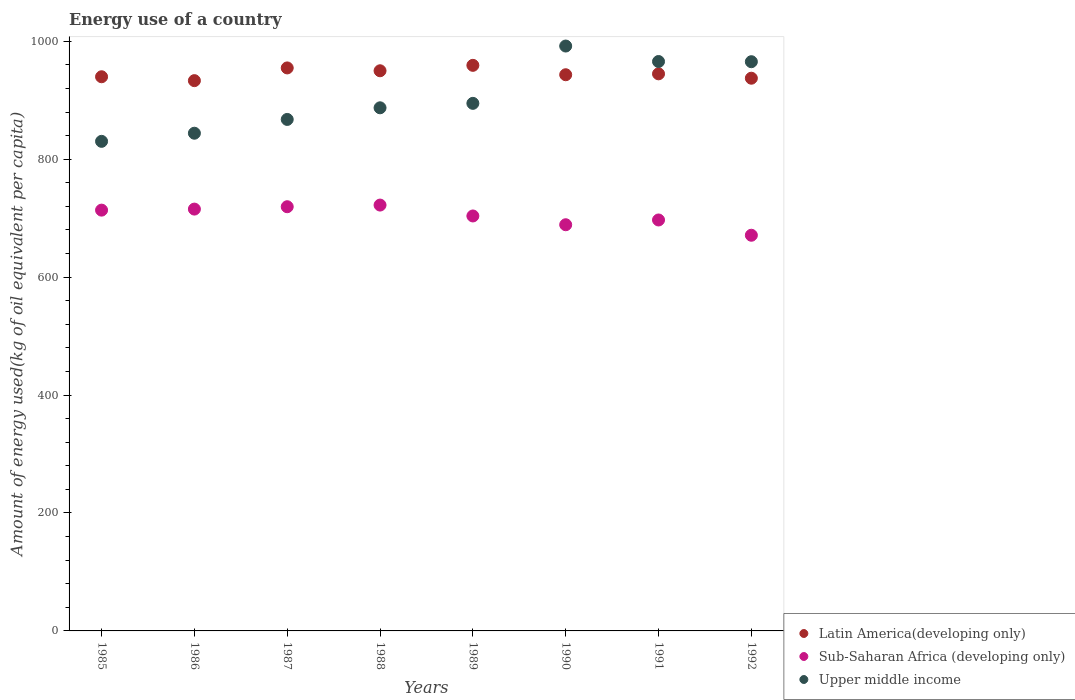How many different coloured dotlines are there?
Provide a short and direct response. 3. Is the number of dotlines equal to the number of legend labels?
Your response must be concise. Yes. What is the amount of energy used in in Sub-Saharan Africa (developing only) in 1987?
Provide a short and direct response. 719.36. Across all years, what is the maximum amount of energy used in in Sub-Saharan Africa (developing only)?
Your answer should be very brief. 722.16. Across all years, what is the minimum amount of energy used in in Latin America(developing only)?
Keep it short and to the point. 933.17. What is the total amount of energy used in in Upper middle income in the graph?
Make the answer very short. 7246.2. What is the difference between the amount of energy used in in Sub-Saharan Africa (developing only) in 1986 and that in 1991?
Make the answer very short. 18.45. What is the difference between the amount of energy used in in Latin America(developing only) in 1989 and the amount of energy used in in Upper middle income in 1990?
Your answer should be compact. -32.74. What is the average amount of energy used in in Sub-Saharan Africa (developing only) per year?
Provide a succinct answer. 703.86. In the year 1992, what is the difference between the amount of energy used in in Upper middle income and amount of energy used in in Sub-Saharan Africa (developing only)?
Keep it short and to the point. 294.29. What is the ratio of the amount of energy used in in Latin America(developing only) in 1987 to that in 1992?
Give a very brief answer. 1.02. Is the amount of energy used in in Latin America(developing only) in 1986 less than that in 1988?
Offer a very short reply. Yes. What is the difference between the highest and the second highest amount of energy used in in Sub-Saharan Africa (developing only)?
Ensure brevity in your answer.  2.8. What is the difference between the highest and the lowest amount of energy used in in Sub-Saharan Africa (developing only)?
Your response must be concise. 51.16. Is it the case that in every year, the sum of the amount of energy used in in Sub-Saharan Africa (developing only) and amount of energy used in in Latin America(developing only)  is greater than the amount of energy used in in Upper middle income?
Make the answer very short. Yes. Is the amount of energy used in in Latin America(developing only) strictly greater than the amount of energy used in in Upper middle income over the years?
Keep it short and to the point. No. Is the amount of energy used in in Upper middle income strictly less than the amount of energy used in in Latin America(developing only) over the years?
Your answer should be very brief. No. How many dotlines are there?
Your answer should be compact. 3. Are the values on the major ticks of Y-axis written in scientific E-notation?
Your answer should be very brief. No. How many legend labels are there?
Your response must be concise. 3. What is the title of the graph?
Provide a short and direct response. Energy use of a country. What is the label or title of the Y-axis?
Your answer should be very brief. Amount of energy used(kg of oil equivalent per capita). What is the Amount of energy used(kg of oil equivalent per capita) in Latin America(developing only) in 1985?
Provide a short and direct response. 939.76. What is the Amount of energy used(kg of oil equivalent per capita) of Sub-Saharan Africa (developing only) in 1985?
Give a very brief answer. 713.59. What is the Amount of energy used(kg of oil equivalent per capita) in Upper middle income in 1985?
Keep it short and to the point. 830.24. What is the Amount of energy used(kg of oil equivalent per capita) of Latin America(developing only) in 1986?
Your answer should be very brief. 933.17. What is the Amount of energy used(kg of oil equivalent per capita) of Sub-Saharan Africa (developing only) in 1986?
Keep it short and to the point. 715.34. What is the Amount of energy used(kg of oil equivalent per capita) of Upper middle income in 1986?
Make the answer very short. 844.02. What is the Amount of energy used(kg of oil equivalent per capita) of Latin America(developing only) in 1987?
Make the answer very short. 954.75. What is the Amount of energy used(kg of oil equivalent per capita) in Sub-Saharan Africa (developing only) in 1987?
Offer a terse response. 719.36. What is the Amount of energy used(kg of oil equivalent per capita) of Upper middle income in 1987?
Offer a very short reply. 867.39. What is the Amount of energy used(kg of oil equivalent per capita) in Latin America(developing only) in 1988?
Your answer should be compact. 949.92. What is the Amount of energy used(kg of oil equivalent per capita) of Sub-Saharan Africa (developing only) in 1988?
Give a very brief answer. 722.16. What is the Amount of energy used(kg of oil equivalent per capita) in Upper middle income in 1988?
Your answer should be very brief. 887.13. What is the Amount of energy used(kg of oil equivalent per capita) in Latin America(developing only) in 1989?
Provide a short and direct response. 959.12. What is the Amount of energy used(kg of oil equivalent per capita) in Sub-Saharan Africa (developing only) in 1989?
Your response must be concise. 703.69. What is the Amount of energy used(kg of oil equivalent per capita) in Upper middle income in 1989?
Your answer should be very brief. 894.65. What is the Amount of energy used(kg of oil equivalent per capita) of Latin America(developing only) in 1990?
Keep it short and to the point. 943.19. What is the Amount of energy used(kg of oil equivalent per capita) of Sub-Saharan Africa (developing only) in 1990?
Your response must be concise. 688.81. What is the Amount of energy used(kg of oil equivalent per capita) in Upper middle income in 1990?
Give a very brief answer. 991.86. What is the Amount of energy used(kg of oil equivalent per capita) of Latin America(developing only) in 1991?
Provide a short and direct response. 944.73. What is the Amount of energy used(kg of oil equivalent per capita) in Sub-Saharan Africa (developing only) in 1991?
Your response must be concise. 696.9. What is the Amount of energy used(kg of oil equivalent per capita) in Upper middle income in 1991?
Offer a terse response. 965.62. What is the Amount of energy used(kg of oil equivalent per capita) in Latin America(developing only) in 1992?
Make the answer very short. 937.3. What is the Amount of energy used(kg of oil equivalent per capita) of Sub-Saharan Africa (developing only) in 1992?
Give a very brief answer. 670.99. What is the Amount of energy used(kg of oil equivalent per capita) in Upper middle income in 1992?
Provide a succinct answer. 965.29. Across all years, what is the maximum Amount of energy used(kg of oil equivalent per capita) of Latin America(developing only)?
Your answer should be compact. 959.12. Across all years, what is the maximum Amount of energy used(kg of oil equivalent per capita) of Sub-Saharan Africa (developing only)?
Your answer should be very brief. 722.16. Across all years, what is the maximum Amount of energy used(kg of oil equivalent per capita) of Upper middle income?
Offer a terse response. 991.86. Across all years, what is the minimum Amount of energy used(kg of oil equivalent per capita) of Latin America(developing only)?
Your answer should be compact. 933.17. Across all years, what is the minimum Amount of energy used(kg of oil equivalent per capita) of Sub-Saharan Africa (developing only)?
Offer a very short reply. 670.99. Across all years, what is the minimum Amount of energy used(kg of oil equivalent per capita) of Upper middle income?
Give a very brief answer. 830.24. What is the total Amount of energy used(kg of oil equivalent per capita) of Latin America(developing only) in the graph?
Keep it short and to the point. 7561.93. What is the total Amount of energy used(kg of oil equivalent per capita) of Sub-Saharan Africa (developing only) in the graph?
Provide a succinct answer. 5630.85. What is the total Amount of energy used(kg of oil equivalent per capita) in Upper middle income in the graph?
Provide a succinct answer. 7246.2. What is the difference between the Amount of energy used(kg of oil equivalent per capita) in Latin America(developing only) in 1985 and that in 1986?
Your answer should be very brief. 6.59. What is the difference between the Amount of energy used(kg of oil equivalent per capita) in Sub-Saharan Africa (developing only) in 1985 and that in 1986?
Provide a succinct answer. -1.75. What is the difference between the Amount of energy used(kg of oil equivalent per capita) of Upper middle income in 1985 and that in 1986?
Your answer should be compact. -13.78. What is the difference between the Amount of energy used(kg of oil equivalent per capita) in Latin America(developing only) in 1985 and that in 1987?
Provide a short and direct response. -14.99. What is the difference between the Amount of energy used(kg of oil equivalent per capita) of Sub-Saharan Africa (developing only) in 1985 and that in 1987?
Your answer should be very brief. -5.77. What is the difference between the Amount of energy used(kg of oil equivalent per capita) in Upper middle income in 1985 and that in 1987?
Give a very brief answer. -37.15. What is the difference between the Amount of energy used(kg of oil equivalent per capita) in Latin America(developing only) in 1985 and that in 1988?
Ensure brevity in your answer.  -10.17. What is the difference between the Amount of energy used(kg of oil equivalent per capita) of Sub-Saharan Africa (developing only) in 1985 and that in 1988?
Keep it short and to the point. -8.57. What is the difference between the Amount of energy used(kg of oil equivalent per capita) of Upper middle income in 1985 and that in 1988?
Your answer should be very brief. -56.89. What is the difference between the Amount of energy used(kg of oil equivalent per capita) in Latin America(developing only) in 1985 and that in 1989?
Offer a very short reply. -19.36. What is the difference between the Amount of energy used(kg of oil equivalent per capita) of Sub-Saharan Africa (developing only) in 1985 and that in 1989?
Give a very brief answer. 9.9. What is the difference between the Amount of energy used(kg of oil equivalent per capita) of Upper middle income in 1985 and that in 1989?
Offer a very short reply. -64.42. What is the difference between the Amount of energy used(kg of oil equivalent per capita) of Latin America(developing only) in 1985 and that in 1990?
Your response must be concise. -3.43. What is the difference between the Amount of energy used(kg of oil equivalent per capita) in Sub-Saharan Africa (developing only) in 1985 and that in 1990?
Offer a very short reply. 24.78. What is the difference between the Amount of energy used(kg of oil equivalent per capita) of Upper middle income in 1985 and that in 1990?
Ensure brevity in your answer.  -161.63. What is the difference between the Amount of energy used(kg of oil equivalent per capita) of Latin America(developing only) in 1985 and that in 1991?
Offer a very short reply. -4.97. What is the difference between the Amount of energy used(kg of oil equivalent per capita) in Sub-Saharan Africa (developing only) in 1985 and that in 1991?
Offer a terse response. 16.69. What is the difference between the Amount of energy used(kg of oil equivalent per capita) of Upper middle income in 1985 and that in 1991?
Your answer should be compact. -135.38. What is the difference between the Amount of energy used(kg of oil equivalent per capita) of Latin America(developing only) in 1985 and that in 1992?
Make the answer very short. 2.46. What is the difference between the Amount of energy used(kg of oil equivalent per capita) of Sub-Saharan Africa (developing only) in 1985 and that in 1992?
Your response must be concise. 42.6. What is the difference between the Amount of energy used(kg of oil equivalent per capita) of Upper middle income in 1985 and that in 1992?
Offer a terse response. -135.05. What is the difference between the Amount of energy used(kg of oil equivalent per capita) of Latin America(developing only) in 1986 and that in 1987?
Offer a very short reply. -21.58. What is the difference between the Amount of energy used(kg of oil equivalent per capita) of Sub-Saharan Africa (developing only) in 1986 and that in 1987?
Make the answer very short. -4.02. What is the difference between the Amount of energy used(kg of oil equivalent per capita) in Upper middle income in 1986 and that in 1987?
Your response must be concise. -23.37. What is the difference between the Amount of energy used(kg of oil equivalent per capita) in Latin America(developing only) in 1986 and that in 1988?
Provide a succinct answer. -16.76. What is the difference between the Amount of energy used(kg of oil equivalent per capita) of Sub-Saharan Africa (developing only) in 1986 and that in 1988?
Make the answer very short. -6.81. What is the difference between the Amount of energy used(kg of oil equivalent per capita) in Upper middle income in 1986 and that in 1988?
Your response must be concise. -43.11. What is the difference between the Amount of energy used(kg of oil equivalent per capita) of Latin America(developing only) in 1986 and that in 1989?
Your answer should be very brief. -25.95. What is the difference between the Amount of energy used(kg of oil equivalent per capita) of Sub-Saharan Africa (developing only) in 1986 and that in 1989?
Keep it short and to the point. 11.65. What is the difference between the Amount of energy used(kg of oil equivalent per capita) in Upper middle income in 1986 and that in 1989?
Offer a very short reply. -50.64. What is the difference between the Amount of energy used(kg of oil equivalent per capita) in Latin America(developing only) in 1986 and that in 1990?
Keep it short and to the point. -10.02. What is the difference between the Amount of energy used(kg of oil equivalent per capita) in Sub-Saharan Africa (developing only) in 1986 and that in 1990?
Your response must be concise. 26.53. What is the difference between the Amount of energy used(kg of oil equivalent per capita) in Upper middle income in 1986 and that in 1990?
Offer a terse response. -147.85. What is the difference between the Amount of energy used(kg of oil equivalent per capita) in Latin America(developing only) in 1986 and that in 1991?
Make the answer very short. -11.56. What is the difference between the Amount of energy used(kg of oil equivalent per capita) in Sub-Saharan Africa (developing only) in 1986 and that in 1991?
Make the answer very short. 18.45. What is the difference between the Amount of energy used(kg of oil equivalent per capita) in Upper middle income in 1986 and that in 1991?
Keep it short and to the point. -121.6. What is the difference between the Amount of energy used(kg of oil equivalent per capita) in Latin America(developing only) in 1986 and that in 1992?
Ensure brevity in your answer.  -4.13. What is the difference between the Amount of energy used(kg of oil equivalent per capita) in Sub-Saharan Africa (developing only) in 1986 and that in 1992?
Your answer should be compact. 44.35. What is the difference between the Amount of energy used(kg of oil equivalent per capita) of Upper middle income in 1986 and that in 1992?
Your answer should be compact. -121.27. What is the difference between the Amount of energy used(kg of oil equivalent per capita) of Latin America(developing only) in 1987 and that in 1988?
Give a very brief answer. 4.82. What is the difference between the Amount of energy used(kg of oil equivalent per capita) of Sub-Saharan Africa (developing only) in 1987 and that in 1988?
Offer a very short reply. -2.8. What is the difference between the Amount of energy used(kg of oil equivalent per capita) in Upper middle income in 1987 and that in 1988?
Ensure brevity in your answer.  -19.74. What is the difference between the Amount of energy used(kg of oil equivalent per capita) of Latin America(developing only) in 1987 and that in 1989?
Offer a terse response. -4.38. What is the difference between the Amount of energy used(kg of oil equivalent per capita) of Sub-Saharan Africa (developing only) in 1987 and that in 1989?
Your answer should be compact. 15.67. What is the difference between the Amount of energy used(kg of oil equivalent per capita) in Upper middle income in 1987 and that in 1989?
Keep it short and to the point. -27.26. What is the difference between the Amount of energy used(kg of oil equivalent per capita) in Latin America(developing only) in 1987 and that in 1990?
Offer a very short reply. 11.56. What is the difference between the Amount of energy used(kg of oil equivalent per capita) of Sub-Saharan Africa (developing only) in 1987 and that in 1990?
Offer a terse response. 30.55. What is the difference between the Amount of energy used(kg of oil equivalent per capita) of Upper middle income in 1987 and that in 1990?
Offer a terse response. -124.47. What is the difference between the Amount of energy used(kg of oil equivalent per capita) in Latin America(developing only) in 1987 and that in 1991?
Ensure brevity in your answer.  10.01. What is the difference between the Amount of energy used(kg of oil equivalent per capita) in Sub-Saharan Africa (developing only) in 1987 and that in 1991?
Provide a short and direct response. 22.47. What is the difference between the Amount of energy used(kg of oil equivalent per capita) in Upper middle income in 1987 and that in 1991?
Offer a terse response. -98.23. What is the difference between the Amount of energy used(kg of oil equivalent per capita) in Latin America(developing only) in 1987 and that in 1992?
Provide a succinct answer. 17.45. What is the difference between the Amount of energy used(kg of oil equivalent per capita) of Sub-Saharan Africa (developing only) in 1987 and that in 1992?
Provide a short and direct response. 48.37. What is the difference between the Amount of energy used(kg of oil equivalent per capita) in Upper middle income in 1987 and that in 1992?
Provide a short and direct response. -97.9. What is the difference between the Amount of energy used(kg of oil equivalent per capita) in Latin America(developing only) in 1988 and that in 1989?
Offer a terse response. -9.2. What is the difference between the Amount of energy used(kg of oil equivalent per capita) of Sub-Saharan Africa (developing only) in 1988 and that in 1989?
Your answer should be very brief. 18.47. What is the difference between the Amount of energy used(kg of oil equivalent per capita) in Upper middle income in 1988 and that in 1989?
Give a very brief answer. -7.53. What is the difference between the Amount of energy used(kg of oil equivalent per capita) in Latin America(developing only) in 1988 and that in 1990?
Your answer should be very brief. 6.74. What is the difference between the Amount of energy used(kg of oil equivalent per capita) of Sub-Saharan Africa (developing only) in 1988 and that in 1990?
Offer a very short reply. 33.35. What is the difference between the Amount of energy used(kg of oil equivalent per capita) of Upper middle income in 1988 and that in 1990?
Provide a short and direct response. -104.74. What is the difference between the Amount of energy used(kg of oil equivalent per capita) in Latin America(developing only) in 1988 and that in 1991?
Your response must be concise. 5.19. What is the difference between the Amount of energy used(kg of oil equivalent per capita) in Sub-Saharan Africa (developing only) in 1988 and that in 1991?
Your answer should be very brief. 25.26. What is the difference between the Amount of energy used(kg of oil equivalent per capita) of Upper middle income in 1988 and that in 1991?
Your answer should be compact. -78.49. What is the difference between the Amount of energy used(kg of oil equivalent per capita) in Latin America(developing only) in 1988 and that in 1992?
Make the answer very short. 12.63. What is the difference between the Amount of energy used(kg of oil equivalent per capita) of Sub-Saharan Africa (developing only) in 1988 and that in 1992?
Offer a terse response. 51.16. What is the difference between the Amount of energy used(kg of oil equivalent per capita) of Upper middle income in 1988 and that in 1992?
Provide a short and direct response. -78.16. What is the difference between the Amount of energy used(kg of oil equivalent per capita) in Latin America(developing only) in 1989 and that in 1990?
Keep it short and to the point. 15.94. What is the difference between the Amount of energy used(kg of oil equivalent per capita) in Sub-Saharan Africa (developing only) in 1989 and that in 1990?
Give a very brief answer. 14.88. What is the difference between the Amount of energy used(kg of oil equivalent per capita) of Upper middle income in 1989 and that in 1990?
Offer a very short reply. -97.21. What is the difference between the Amount of energy used(kg of oil equivalent per capita) in Latin America(developing only) in 1989 and that in 1991?
Ensure brevity in your answer.  14.39. What is the difference between the Amount of energy used(kg of oil equivalent per capita) of Sub-Saharan Africa (developing only) in 1989 and that in 1991?
Keep it short and to the point. 6.79. What is the difference between the Amount of energy used(kg of oil equivalent per capita) of Upper middle income in 1989 and that in 1991?
Your answer should be very brief. -70.96. What is the difference between the Amount of energy used(kg of oil equivalent per capita) in Latin America(developing only) in 1989 and that in 1992?
Offer a terse response. 21.82. What is the difference between the Amount of energy used(kg of oil equivalent per capita) of Sub-Saharan Africa (developing only) in 1989 and that in 1992?
Offer a very short reply. 32.7. What is the difference between the Amount of energy used(kg of oil equivalent per capita) of Upper middle income in 1989 and that in 1992?
Keep it short and to the point. -70.63. What is the difference between the Amount of energy used(kg of oil equivalent per capita) in Latin America(developing only) in 1990 and that in 1991?
Ensure brevity in your answer.  -1.55. What is the difference between the Amount of energy used(kg of oil equivalent per capita) of Sub-Saharan Africa (developing only) in 1990 and that in 1991?
Provide a succinct answer. -8.09. What is the difference between the Amount of energy used(kg of oil equivalent per capita) in Upper middle income in 1990 and that in 1991?
Your answer should be very brief. 26.25. What is the difference between the Amount of energy used(kg of oil equivalent per capita) in Latin America(developing only) in 1990 and that in 1992?
Keep it short and to the point. 5.89. What is the difference between the Amount of energy used(kg of oil equivalent per capita) in Sub-Saharan Africa (developing only) in 1990 and that in 1992?
Make the answer very short. 17.82. What is the difference between the Amount of energy used(kg of oil equivalent per capita) in Upper middle income in 1990 and that in 1992?
Offer a terse response. 26.58. What is the difference between the Amount of energy used(kg of oil equivalent per capita) in Latin America(developing only) in 1991 and that in 1992?
Make the answer very short. 7.43. What is the difference between the Amount of energy used(kg of oil equivalent per capita) in Sub-Saharan Africa (developing only) in 1991 and that in 1992?
Ensure brevity in your answer.  25.9. What is the difference between the Amount of energy used(kg of oil equivalent per capita) of Upper middle income in 1991 and that in 1992?
Provide a succinct answer. 0.33. What is the difference between the Amount of energy used(kg of oil equivalent per capita) of Latin America(developing only) in 1985 and the Amount of energy used(kg of oil equivalent per capita) of Sub-Saharan Africa (developing only) in 1986?
Give a very brief answer. 224.41. What is the difference between the Amount of energy used(kg of oil equivalent per capita) in Latin America(developing only) in 1985 and the Amount of energy used(kg of oil equivalent per capita) in Upper middle income in 1986?
Give a very brief answer. 95.74. What is the difference between the Amount of energy used(kg of oil equivalent per capita) in Sub-Saharan Africa (developing only) in 1985 and the Amount of energy used(kg of oil equivalent per capita) in Upper middle income in 1986?
Offer a very short reply. -130.42. What is the difference between the Amount of energy used(kg of oil equivalent per capita) of Latin America(developing only) in 1985 and the Amount of energy used(kg of oil equivalent per capita) of Sub-Saharan Africa (developing only) in 1987?
Provide a short and direct response. 220.4. What is the difference between the Amount of energy used(kg of oil equivalent per capita) in Latin America(developing only) in 1985 and the Amount of energy used(kg of oil equivalent per capita) in Upper middle income in 1987?
Keep it short and to the point. 72.37. What is the difference between the Amount of energy used(kg of oil equivalent per capita) of Sub-Saharan Africa (developing only) in 1985 and the Amount of energy used(kg of oil equivalent per capita) of Upper middle income in 1987?
Make the answer very short. -153.8. What is the difference between the Amount of energy used(kg of oil equivalent per capita) in Latin America(developing only) in 1985 and the Amount of energy used(kg of oil equivalent per capita) in Sub-Saharan Africa (developing only) in 1988?
Provide a succinct answer. 217.6. What is the difference between the Amount of energy used(kg of oil equivalent per capita) of Latin America(developing only) in 1985 and the Amount of energy used(kg of oil equivalent per capita) of Upper middle income in 1988?
Your response must be concise. 52.63. What is the difference between the Amount of energy used(kg of oil equivalent per capita) of Sub-Saharan Africa (developing only) in 1985 and the Amount of energy used(kg of oil equivalent per capita) of Upper middle income in 1988?
Your answer should be very brief. -173.54. What is the difference between the Amount of energy used(kg of oil equivalent per capita) in Latin America(developing only) in 1985 and the Amount of energy used(kg of oil equivalent per capita) in Sub-Saharan Africa (developing only) in 1989?
Provide a short and direct response. 236.07. What is the difference between the Amount of energy used(kg of oil equivalent per capita) of Latin America(developing only) in 1985 and the Amount of energy used(kg of oil equivalent per capita) of Upper middle income in 1989?
Make the answer very short. 45.1. What is the difference between the Amount of energy used(kg of oil equivalent per capita) in Sub-Saharan Africa (developing only) in 1985 and the Amount of energy used(kg of oil equivalent per capita) in Upper middle income in 1989?
Provide a short and direct response. -181.06. What is the difference between the Amount of energy used(kg of oil equivalent per capita) in Latin America(developing only) in 1985 and the Amount of energy used(kg of oil equivalent per capita) in Sub-Saharan Africa (developing only) in 1990?
Offer a terse response. 250.95. What is the difference between the Amount of energy used(kg of oil equivalent per capita) of Latin America(developing only) in 1985 and the Amount of energy used(kg of oil equivalent per capita) of Upper middle income in 1990?
Keep it short and to the point. -52.11. What is the difference between the Amount of energy used(kg of oil equivalent per capita) of Sub-Saharan Africa (developing only) in 1985 and the Amount of energy used(kg of oil equivalent per capita) of Upper middle income in 1990?
Keep it short and to the point. -278.27. What is the difference between the Amount of energy used(kg of oil equivalent per capita) of Latin America(developing only) in 1985 and the Amount of energy used(kg of oil equivalent per capita) of Sub-Saharan Africa (developing only) in 1991?
Keep it short and to the point. 242.86. What is the difference between the Amount of energy used(kg of oil equivalent per capita) in Latin America(developing only) in 1985 and the Amount of energy used(kg of oil equivalent per capita) in Upper middle income in 1991?
Offer a terse response. -25.86. What is the difference between the Amount of energy used(kg of oil equivalent per capita) of Sub-Saharan Africa (developing only) in 1985 and the Amount of energy used(kg of oil equivalent per capita) of Upper middle income in 1991?
Offer a terse response. -252.03. What is the difference between the Amount of energy used(kg of oil equivalent per capita) of Latin America(developing only) in 1985 and the Amount of energy used(kg of oil equivalent per capita) of Sub-Saharan Africa (developing only) in 1992?
Ensure brevity in your answer.  268.76. What is the difference between the Amount of energy used(kg of oil equivalent per capita) in Latin America(developing only) in 1985 and the Amount of energy used(kg of oil equivalent per capita) in Upper middle income in 1992?
Offer a terse response. -25.53. What is the difference between the Amount of energy used(kg of oil equivalent per capita) in Sub-Saharan Africa (developing only) in 1985 and the Amount of energy used(kg of oil equivalent per capita) in Upper middle income in 1992?
Provide a short and direct response. -251.7. What is the difference between the Amount of energy used(kg of oil equivalent per capita) of Latin America(developing only) in 1986 and the Amount of energy used(kg of oil equivalent per capita) of Sub-Saharan Africa (developing only) in 1987?
Keep it short and to the point. 213.81. What is the difference between the Amount of energy used(kg of oil equivalent per capita) in Latin America(developing only) in 1986 and the Amount of energy used(kg of oil equivalent per capita) in Upper middle income in 1987?
Your response must be concise. 65.78. What is the difference between the Amount of energy used(kg of oil equivalent per capita) of Sub-Saharan Africa (developing only) in 1986 and the Amount of energy used(kg of oil equivalent per capita) of Upper middle income in 1987?
Provide a short and direct response. -152.05. What is the difference between the Amount of energy used(kg of oil equivalent per capita) of Latin America(developing only) in 1986 and the Amount of energy used(kg of oil equivalent per capita) of Sub-Saharan Africa (developing only) in 1988?
Offer a terse response. 211.01. What is the difference between the Amount of energy used(kg of oil equivalent per capita) of Latin America(developing only) in 1986 and the Amount of energy used(kg of oil equivalent per capita) of Upper middle income in 1988?
Ensure brevity in your answer.  46.04. What is the difference between the Amount of energy used(kg of oil equivalent per capita) in Sub-Saharan Africa (developing only) in 1986 and the Amount of energy used(kg of oil equivalent per capita) in Upper middle income in 1988?
Offer a terse response. -171.78. What is the difference between the Amount of energy used(kg of oil equivalent per capita) in Latin America(developing only) in 1986 and the Amount of energy used(kg of oil equivalent per capita) in Sub-Saharan Africa (developing only) in 1989?
Offer a terse response. 229.48. What is the difference between the Amount of energy used(kg of oil equivalent per capita) in Latin America(developing only) in 1986 and the Amount of energy used(kg of oil equivalent per capita) in Upper middle income in 1989?
Your answer should be compact. 38.51. What is the difference between the Amount of energy used(kg of oil equivalent per capita) of Sub-Saharan Africa (developing only) in 1986 and the Amount of energy used(kg of oil equivalent per capita) of Upper middle income in 1989?
Your response must be concise. -179.31. What is the difference between the Amount of energy used(kg of oil equivalent per capita) of Latin America(developing only) in 1986 and the Amount of energy used(kg of oil equivalent per capita) of Sub-Saharan Africa (developing only) in 1990?
Keep it short and to the point. 244.36. What is the difference between the Amount of energy used(kg of oil equivalent per capita) of Latin America(developing only) in 1986 and the Amount of energy used(kg of oil equivalent per capita) of Upper middle income in 1990?
Keep it short and to the point. -58.7. What is the difference between the Amount of energy used(kg of oil equivalent per capita) in Sub-Saharan Africa (developing only) in 1986 and the Amount of energy used(kg of oil equivalent per capita) in Upper middle income in 1990?
Offer a terse response. -276.52. What is the difference between the Amount of energy used(kg of oil equivalent per capita) of Latin America(developing only) in 1986 and the Amount of energy used(kg of oil equivalent per capita) of Sub-Saharan Africa (developing only) in 1991?
Offer a terse response. 236.27. What is the difference between the Amount of energy used(kg of oil equivalent per capita) in Latin America(developing only) in 1986 and the Amount of energy used(kg of oil equivalent per capita) in Upper middle income in 1991?
Provide a succinct answer. -32.45. What is the difference between the Amount of energy used(kg of oil equivalent per capita) in Sub-Saharan Africa (developing only) in 1986 and the Amount of energy used(kg of oil equivalent per capita) in Upper middle income in 1991?
Give a very brief answer. -250.27. What is the difference between the Amount of energy used(kg of oil equivalent per capita) in Latin America(developing only) in 1986 and the Amount of energy used(kg of oil equivalent per capita) in Sub-Saharan Africa (developing only) in 1992?
Your answer should be very brief. 262.17. What is the difference between the Amount of energy used(kg of oil equivalent per capita) in Latin America(developing only) in 1986 and the Amount of energy used(kg of oil equivalent per capita) in Upper middle income in 1992?
Your answer should be very brief. -32.12. What is the difference between the Amount of energy used(kg of oil equivalent per capita) in Sub-Saharan Africa (developing only) in 1986 and the Amount of energy used(kg of oil equivalent per capita) in Upper middle income in 1992?
Provide a succinct answer. -249.94. What is the difference between the Amount of energy used(kg of oil equivalent per capita) in Latin America(developing only) in 1987 and the Amount of energy used(kg of oil equivalent per capita) in Sub-Saharan Africa (developing only) in 1988?
Offer a very short reply. 232.59. What is the difference between the Amount of energy used(kg of oil equivalent per capita) in Latin America(developing only) in 1987 and the Amount of energy used(kg of oil equivalent per capita) in Upper middle income in 1988?
Make the answer very short. 67.62. What is the difference between the Amount of energy used(kg of oil equivalent per capita) of Sub-Saharan Africa (developing only) in 1987 and the Amount of energy used(kg of oil equivalent per capita) of Upper middle income in 1988?
Your response must be concise. -167.76. What is the difference between the Amount of energy used(kg of oil equivalent per capita) of Latin America(developing only) in 1987 and the Amount of energy used(kg of oil equivalent per capita) of Sub-Saharan Africa (developing only) in 1989?
Offer a terse response. 251.06. What is the difference between the Amount of energy used(kg of oil equivalent per capita) of Latin America(developing only) in 1987 and the Amount of energy used(kg of oil equivalent per capita) of Upper middle income in 1989?
Provide a short and direct response. 60.09. What is the difference between the Amount of energy used(kg of oil equivalent per capita) in Sub-Saharan Africa (developing only) in 1987 and the Amount of energy used(kg of oil equivalent per capita) in Upper middle income in 1989?
Make the answer very short. -175.29. What is the difference between the Amount of energy used(kg of oil equivalent per capita) in Latin America(developing only) in 1987 and the Amount of energy used(kg of oil equivalent per capita) in Sub-Saharan Africa (developing only) in 1990?
Provide a succinct answer. 265.94. What is the difference between the Amount of energy used(kg of oil equivalent per capita) of Latin America(developing only) in 1987 and the Amount of energy used(kg of oil equivalent per capita) of Upper middle income in 1990?
Your answer should be very brief. -37.12. What is the difference between the Amount of energy used(kg of oil equivalent per capita) in Sub-Saharan Africa (developing only) in 1987 and the Amount of energy used(kg of oil equivalent per capita) in Upper middle income in 1990?
Offer a very short reply. -272.5. What is the difference between the Amount of energy used(kg of oil equivalent per capita) in Latin America(developing only) in 1987 and the Amount of energy used(kg of oil equivalent per capita) in Sub-Saharan Africa (developing only) in 1991?
Ensure brevity in your answer.  257.85. What is the difference between the Amount of energy used(kg of oil equivalent per capita) of Latin America(developing only) in 1987 and the Amount of energy used(kg of oil equivalent per capita) of Upper middle income in 1991?
Your response must be concise. -10.87. What is the difference between the Amount of energy used(kg of oil equivalent per capita) of Sub-Saharan Africa (developing only) in 1987 and the Amount of energy used(kg of oil equivalent per capita) of Upper middle income in 1991?
Provide a short and direct response. -246.26. What is the difference between the Amount of energy used(kg of oil equivalent per capita) in Latin America(developing only) in 1987 and the Amount of energy used(kg of oil equivalent per capita) in Sub-Saharan Africa (developing only) in 1992?
Offer a terse response. 283.75. What is the difference between the Amount of energy used(kg of oil equivalent per capita) in Latin America(developing only) in 1987 and the Amount of energy used(kg of oil equivalent per capita) in Upper middle income in 1992?
Keep it short and to the point. -10.54. What is the difference between the Amount of energy used(kg of oil equivalent per capita) of Sub-Saharan Africa (developing only) in 1987 and the Amount of energy used(kg of oil equivalent per capita) of Upper middle income in 1992?
Offer a terse response. -245.92. What is the difference between the Amount of energy used(kg of oil equivalent per capita) of Latin America(developing only) in 1988 and the Amount of energy used(kg of oil equivalent per capita) of Sub-Saharan Africa (developing only) in 1989?
Provide a short and direct response. 246.24. What is the difference between the Amount of energy used(kg of oil equivalent per capita) of Latin America(developing only) in 1988 and the Amount of energy used(kg of oil equivalent per capita) of Upper middle income in 1989?
Give a very brief answer. 55.27. What is the difference between the Amount of energy used(kg of oil equivalent per capita) of Sub-Saharan Africa (developing only) in 1988 and the Amount of energy used(kg of oil equivalent per capita) of Upper middle income in 1989?
Offer a very short reply. -172.5. What is the difference between the Amount of energy used(kg of oil equivalent per capita) in Latin America(developing only) in 1988 and the Amount of energy used(kg of oil equivalent per capita) in Sub-Saharan Africa (developing only) in 1990?
Offer a very short reply. 261.12. What is the difference between the Amount of energy used(kg of oil equivalent per capita) of Latin America(developing only) in 1988 and the Amount of energy used(kg of oil equivalent per capita) of Upper middle income in 1990?
Offer a terse response. -41.94. What is the difference between the Amount of energy used(kg of oil equivalent per capita) of Sub-Saharan Africa (developing only) in 1988 and the Amount of energy used(kg of oil equivalent per capita) of Upper middle income in 1990?
Give a very brief answer. -269.71. What is the difference between the Amount of energy used(kg of oil equivalent per capita) in Latin America(developing only) in 1988 and the Amount of energy used(kg of oil equivalent per capita) in Sub-Saharan Africa (developing only) in 1991?
Your answer should be very brief. 253.03. What is the difference between the Amount of energy used(kg of oil equivalent per capita) of Latin America(developing only) in 1988 and the Amount of energy used(kg of oil equivalent per capita) of Upper middle income in 1991?
Your answer should be very brief. -15.69. What is the difference between the Amount of energy used(kg of oil equivalent per capita) in Sub-Saharan Africa (developing only) in 1988 and the Amount of energy used(kg of oil equivalent per capita) in Upper middle income in 1991?
Your answer should be very brief. -243.46. What is the difference between the Amount of energy used(kg of oil equivalent per capita) of Latin America(developing only) in 1988 and the Amount of energy used(kg of oil equivalent per capita) of Sub-Saharan Africa (developing only) in 1992?
Your answer should be very brief. 278.93. What is the difference between the Amount of energy used(kg of oil equivalent per capita) in Latin America(developing only) in 1988 and the Amount of energy used(kg of oil equivalent per capita) in Upper middle income in 1992?
Your response must be concise. -15.36. What is the difference between the Amount of energy used(kg of oil equivalent per capita) in Sub-Saharan Africa (developing only) in 1988 and the Amount of energy used(kg of oil equivalent per capita) in Upper middle income in 1992?
Your answer should be very brief. -243.13. What is the difference between the Amount of energy used(kg of oil equivalent per capita) of Latin America(developing only) in 1989 and the Amount of energy used(kg of oil equivalent per capita) of Sub-Saharan Africa (developing only) in 1990?
Make the answer very short. 270.31. What is the difference between the Amount of energy used(kg of oil equivalent per capita) in Latin America(developing only) in 1989 and the Amount of energy used(kg of oil equivalent per capita) in Upper middle income in 1990?
Your response must be concise. -32.74. What is the difference between the Amount of energy used(kg of oil equivalent per capita) in Sub-Saharan Africa (developing only) in 1989 and the Amount of energy used(kg of oil equivalent per capita) in Upper middle income in 1990?
Provide a succinct answer. -288.17. What is the difference between the Amount of energy used(kg of oil equivalent per capita) of Latin America(developing only) in 1989 and the Amount of energy used(kg of oil equivalent per capita) of Sub-Saharan Africa (developing only) in 1991?
Offer a terse response. 262.22. What is the difference between the Amount of energy used(kg of oil equivalent per capita) in Latin America(developing only) in 1989 and the Amount of energy used(kg of oil equivalent per capita) in Upper middle income in 1991?
Your response must be concise. -6.5. What is the difference between the Amount of energy used(kg of oil equivalent per capita) in Sub-Saharan Africa (developing only) in 1989 and the Amount of energy used(kg of oil equivalent per capita) in Upper middle income in 1991?
Offer a very short reply. -261.93. What is the difference between the Amount of energy used(kg of oil equivalent per capita) of Latin America(developing only) in 1989 and the Amount of energy used(kg of oil equivalent per capita) of Sub-Saharan Africa (developing only) in 1992?
Provide a succinct answer. 288.13. What is the difference between the Amount of energy used(kg of oil equivalent per capita) of Latin America(developing only) in 1989 and the Amount of energy used(kg of oil equivalent per capita) of Upper middle income in 1992?
Offer a very short reply. -6.17. What is the difference between the Amount of energy used(kg of oil equivalent per capita) in Sub-Saharan Africa (developing only) in 1989 and the Amount of energy used(kg of oil equivalent per capita) in Upper middle income in 1992?
Your response must be concise. -261.6. What is the difference between the Amount of energy used(kg of oil equivalent per capita) of Latin America(developing only) in 1990 and the Amount of energy used(kg of oil equivalent per capita) of Sub-Saharan Africa (developing only) in 1991?
Your response must be concise. 246.29. What is the difference between the Amount of energy used(kg of oil equivalent per capita) of Latin America(developing only) in 1990 and the Amount of energy used(kg of oil equivalent per capita) of Upper middle income in 1991?
Ensure brevity in your answer.  -22.43. What is the difference between the Amount of energy used(kg of oil equivalent per capita) in Sub-Saharan Africa (developing only) in 1990 and the Amount of energy used(kg of oil equivalent per capita) in Upper middle income in 1991?
Your response must be concise. -276.81. What is the difference between the Amount of energy used(kg of oil equivalent per capita) of Latin America(developing only) in 1990 and the Amount of energy used(kg of oil equivalent per capita) of Sub-Saharan Africa (developing only) in 1992?
Make the answer very short. 272.19. What is the difference between the Amount of energy used(kg of oil equivalent per capita) of Latin America(developing only) in 1990 and the Amount of energy used(kg of oil equivalent per capita) of Upper middle income in 1992?
Your answer should be very brief. -22.1. What is the difference between the Amount of energy used(kg of oil equivalent per capita) in Sub-Saharan Africa (developing only) in 1990 and the Amount of energy used(kg of oil equivalent per capita) in Upper middle income in 1992?
Keep it short and to the point. -276.48. What is the difference between the Amount of energy used(kg of oil equivalent per capita) in Latin America(developing only) in 1991 and the Amount of energy used(kg of oil equivalent per capita) in Sub-Saharan Africa (developing only) in 1992?
Offer a terse response. 273.74. What is the difference between the Amount of energy used(kg of oil equivalent per capita) in Latin America(developing only) in 1991 and the Amount of energy used(kg of oil equivalent per capita) in Upper middle income in 1992?
Your answer should be very brief. -20.56. What is the difference between the Amount of energy used(kg of oil equivalent per capita) of Sub-Saharan Africa (developing only) in 1991 and the Amount of energy used(kg of oil equivalent per capita) of Upper middle income in 1992?
Give a very brief answer. -268.39. What is the average Amount of energy used(kg of oil equivalent per capita) of Latin America(developing only) per year?
Your answer should be compact. 945.24. What is the average Amount of energy used(kg of oil equivalent per capita) in Sub-Saharan Africa (developing only) per year?
Your response must be concise. 703.86. What is the average Amount of energy used(kg of oil equivalent per capita) in Upper middle income per year?
Your answer should be very brief. 905.77. In the year 1985, what is the difference between the Amount of energy used(kg of oil equivalent per capita) of Latin America(developing only) and Amount of energy used(kg of oil equivalent per capita) of Sub-Saharan Africa (developing only)?
Your answer should be compact. 226.17. In the year 1985, what is the difference between the Amount of energy used(kg of oil equivalent per capita) of Latin America(developing only) and Amount of energy used(kg of oil equivalent per capita) of Upper middle income?
Your answer should be very brief. 109.52. In the year 1985, what is the difference between the Amount of energy used(kg of oil equivalent per capita) of Sub-Saharan Africa (developing only) and Amount of energy used(kg of oil equivalent per capita) of Upper middle income?
Provide a short and direct response. -116.65. In the year 1986, what is the difference between the Amount of energy used(kg of oil equivalent per capita) of Latin America(developing only) and Amount of energy used(kg of oil equivalent per capita) of Sub-Saharan Africa (developing only)?
Provide a succinct answer. 217.82. In the year 1986, what is the difference between the Amount of energy used(kg of oil equivalent per capita) in Latin America(developing only) and Amount of energy used(kg of oil equivalent per capita) in Upper middle income?
Offer a terse response. 89.15. In the year 1986, what is the difference between the Amount of energy used(kg of oil equivalent per capita) in Sub-Saharan Africa (developing only) and Amount of energy used(kg of oil equivalent per capita) in Upper middle income?
Keep it short and to the point. -128.67. In the year 1987, what is the difference between the Amount of energy used(kg of oil equivalent per capita) in Latin America(developing only) and Amount of energy used(kg of oil equivalent per capita) in Sub-Saharan Africa (developing only)?
Your answer should be very brief. 235.38. In the year 1987, what is the difference between the Amount of energy used(kg of oil equivalent per capita) in Latin America(developing only) and Amount of energy used(kg of oil equivalent per capita) in Upper middle income?
Give a very brief answer. 87.36. In the year 1987, what is the difference between the Amount of energy used(kg of oil equivalent per capita) in Sub-Saharan Africa (developing only) and Amount of energy used(kg of oil equivalent per capita) in Upper middle income?
Provide a short and direct response. -148.03. In the year 1988, what is the difference between the Amount of energy used(kg of oil equivalent per capita) of Latin America(developing only) and Amount of energy used(kg of oil equivalent per capita) of Sub-Saharan Africa (developing only)?
Keep it short and to the point. 227.77. In the year 1988, what is the difference between the Amount of energy used(kg of oil equivalent per capita) in Latin America(developing only) and Amount of energy used(kg of oil equivalent per capita) in Upper middle income?
Ensure brevity in your answer.  62.8. In the year 1988, what is the difference between the Amount of energy used(kg of oil equivalent per capita) in Sub-Saharan Africa (developing only) and Amount of energy used(kg of oil equivalent per capita) in Upper middle income?
Your answer should be very brief. -164.97. In the year 1989, what is the difference between the Amount of energy used(kg of oil equivalent per capita) in Latin America(developing only) and Amount of energy used(kg of oil equivalent per capita) in Sub-Saharan Africa (developing only)?
Keep it short and to the point. 255.43. In the year 1989, what is the difference between the Amount of energy used(kg of oil equivalent per capita) of Latin America(developing only) and Amount of energy used(kg of oil equivalent per capita) of Upper middle income?
Offer a terse response. 64.47. In the year 1989, what is the difference between the Amount of energy used(kg of oil equivalent per capita) of Sub-Saharan Africa (developing only) and Amount of energy used(kg of oil equivalent per capita) of Upper middle income?
Offer a terse response. -190.96. In the year 1990, what is the difference between the Amount of energy used(kg of oil equivalent per capita) of Latin America(developing only) and Amount of energy used(kg of oil equivalent per capita) of Sub-Saharan Africa (developing only)?
Provide a short and direct response. 254.38. In the year 1990, what is the difference between the Amount of energy used(kg of oil equivalent per capita) in Latin America(developing only) and Amount of energy used(kg of oil equivalent per capita) in Upper middle income?
Offer a very short reply. -48.68. In the year 1990, what is the difference between the Amount of energy used(kg of oil equivalent per capita) of Sub-Saharan Africa (developing only) and Amount of energy used(kg of oil equivalent per capita) of Upper middle income?
Your response must be concise. -303.05. In the year 1991, what is the difference between the Amount of energy used(kg of oil equivalent per capita) of Latin America(developing only) and Amount of energy used(kg of oil equivalent per capita) of Sub-Saharan Africa (developing only)?
Offer a very short reply. 247.83. In the year 1991, what is the difference between the Amount of energy used(kg of oil equivalent per capita) in Latin America(developing only) and Amount of energy used(kg of oil equivalent per capita) in Upper middle income?
Provide a succinct answer. -20.89. In the year 1991, what is the difference between the Amount of energy used(kg of oil equivalent per capita) of Sub-Saharan Africa (developing only) and Amount of energy used(kg of oil equivalent per capita) of Upper middle income?
Give a very brief answer. -268.72. In the year 1992, what is the difference between the Amount of energy used(kg of oil equivalent per capita) of Latin America(developing only) and Amount of energy used(kg of oil equivalent per capita) of Sub-Saharan Africa (developing only)?
Keep it short and to the point. 266.3. In the year 1992, what is the difference between the Amount of energy used(kg of oil equivalent per capita) in Latin America(developing only) and Amount of energy used(kg of oil equivalent per capita) in Upper middle income?
Keep it short and to the point. -27.99. In the year 1992, what is the difference between the Amount of energy used(kg of oil equivalent per capita) of Sub-Saharan Africa (developing only) and Amount of energy used(kg of oil equivalent per capita) of Upper middle income?
Make the answer very short. -294.29. What is the ratio of the Amount of energy used(kg of oil equivalent per capita) of Latin America(developing only) in 1985 to that in 1986?
Keep it short and to the point. 1.01. What is the ratio of the Amount of energy used(kg of oil equivalent per capita) of Upper middle income in 1985 to that in 1986?
Provide a short and direct response. 0.98. What is the ratio of the Amount of energy used(kg of oil equivalent per capita) of Latin America(developing only) in 1985 to that in 1987?
Provide a succinct answer. 0.98. What is the ratio of the Amount of energy used(kg of oil equivalent per capita) in Upper middle income in 1985 to that in 1987?
Make the answer very short. 0.96. What is the ratio of the Amount of energy used(kg of oil equivalent per capita) of Latin America(developing only) in 1985 to that in 1988?
Offer a terse response. 0.99. What is the ratio of the Amount of energy used(kg of oil equivalent per capita) in Sub-Saharan Africa (developing only) in 1985 to that in 1988?
Offer a terse response. 0.99. What is the ratio of the Amount of energy used(kg of oil equivalent per capita) of Upper middle income in 1985 to that in 1988?
Your response must be concise. 0.94. What is the ratio of the Amount of energy used(kg of oil equivalent per capita) of Latin America(developing only) in 1985 to that in 1989?
Make the answer very short. 0.98. What is the ratio of the Amount of energy used(kg of oil equivalent per capita) of Sub-Saharan Africa (developing only) in 1985 to that in 1989?
Offer a very short reply. 1.01. What is the ratio of the Amount of energy used(kg of oil equivalent per capita) in Upper middle income in 1985 to that in 1989?
Ensure brevity in your answer.  0.93. What is the ratio of the Amount of energy used(kg of oil equivalent per capita) of Sub-Saharan Africa (developing only) in 1985 to that in 1990?
Offer a very short reply. 1.04. What is the ratio of the Amount of energy used(kg of oil equivalent per capita) in Upper middle income in 1985 to that in 1990?
Provide a succinct answer. 0.84. What is the ratio of the Amount of energy used(kg of oil equivalent per capita) of Latin America(developing only) in 1985 to that in 1991?
Provide a succinct answer. 0.99. What is the ratio of the Amount of energy used(kg of oil equivalent per capita) of Sub-Saharan Africa (developing only) in 1985 to that in 1991?
Provide a succinct answer. 1.02. What is the ratio of the Amount of energy used(kg of oil equivalent per capita) in Upper middle income in 1985 to that in 1991?
Your answer should be very brief. 0.86. What is the ratio of the Amount of energy used(kg of oil equivalent per capita) of Sub-Saharan Africa (developing only) in 1985 to that in 1992?
Give a very brief answer. 1.06. What is the ratio of the Amount of energy used(kg of oil equivalent per capita) in Upper middle income in 1985 to that in 1992?
Your answer should be very brief. 0.86. What is the ratio of the Amount of energy used(kg of oil equivalent per capita) of Latin America(developing only) in 1986 to that in 1987?
Give a very brief answer. 0.98. What is the ratio of the Amount of energy used(kg of oil equivalent per capita) of Sub-Saharan Africa (developing only) in 1986 to that in 1987?
Give a very brief answer. 0.99. What is the ratio of the Amount of energy used(kg of oil equivalent per capita) in Upper middle income in 1986 to that in 1987?
Make the answer very short. 0.97. What is the ratio of the Amount of energy used(kg of oil equivalent per capita) of Latin America(developing only) in 1986 to that in 1988?
Keep it short and to the point. 0.98. What is the ratio of the Amount of energy used(kg of oil equivalent per capita) in Sub-Saharan Africa (developing only) in 1986 to that in 1988?
Offer a very short reply. 0.99. What is the ratio of the Amount of energy used(kg of oil equivalent per capita) in Upper middle income in 1986 to that in 1988?
Offer a very short reply. 0.95. What is the ratio of the Amount of energy used(kg of oil equivalent per capita) of Latin America(developing only) in 1986 to that in 1989?
Offer a terse response. 0.97. What is the ratio of the Amount of energy used(kg of oil equivalent per capita) in Sub-Saharan Africa (developing only) in 1986 to that in 1989?
Offer a terse response. 1.02. What is the ratio of the Amount of energy used(kg of oil equivalent per capita) of Upper middle income in 1986 to that in 1989?
Offer a very short reply. 0.94. What is the ratio of the Amount of energy used(kg of oil equivalent per capita) of Sub-Saharan Africa (developing only) in 1986 to that in 1990?
Offer a terse response. 1.04. What is the ratio of the Amount of energy used(kg of oil equivalent per capita) in Upper middle income in 1986 to that in 1990?
Your answer should be very brief. 0.85. What is the ratio of the Amount of energy used(kg of oil equivalent per capita) of Sub-Saharan Africa (developing only) in 1986 to that in 1991?
Your answer should be very brief. 1.03. What is the ratio of the Amount of energy used(kg of oil equivalent per capita) in Upper middle income in 1986 to that in 1991?
Ensure brevity in your answer.  0.87. What is the ratio of the Amount of energy used(kg of oil equivalent per capita) of Sub-Saharan Africa (developing only) in 1986 to that in 1992?
Make the answer very short. 1.07. What is the ratio of the Amount of energy used(kg of oil equivalent per capita) in Upper middle income in 1986 to that in 1992?
Your response must be concise. 0.87. What is the ratio of the Amount of energy used(kg of oil equivalent per capita) of Sub-Saharan Africa (developing only) in 1987 to that in 1988?
Ensure brevity in your answer.  1. What is the ratio of the Amount of energy used(kg of oil equivalent per capita) of Upper middle income in 1987 to that in 1988?
Give a very brief answer. 0.98. What is the ratio of the Amount of energy used(kg of oil equivalent per capita) of Latin America(developing only) in 1987 to that in 1989?
Your response must be concise. 1. What is the ratio of the Amount of energy used(kg of oil equivalent per capita) of Sub-Saharan Africa (developing only) in 1987 to that in 1989?
Offer a very short reply. 1.02. What is the ratio of the Amount of energy used(kg of oil equivalent per capita) of Upper middle income in 1987 to that in 1989?
Your answer should be very brief. 0.97. What is the ratio of the Amount of energy used(kg of oil equivalent per capita) of Latin America(developing only) in 1987 to that in 1990?
Your response must be concise. 1.01. What is the ratio of the Amount of energy used(kg of oil equivalent per capita) in Sub-Saharan Africa (developing only) in 1987 to that in 1990?
Your response must be concise. 1.04. What is the ratio of the Amount of energy used(kg of oil equivalent per capita) of Upper middle income in 1987 to that in 1990?
Provide a succinct answer. 0.87. What is the ratio of the Amount of energy used(kg of oil equivalent per capita) of Latin America(developing only) in 1987 to that in 1991?
Your response must be concise. 1.01. What is the ratio of the Amount of energy used(kg of oil equivalent per capita) in Sub-Saharan Africa (developing only) in 1987 to that in 1991?
Provide a short and direct response. 1.03. What is the ratio of the Amount of energy used(kg of oil equivalent per capita) of Upper middle income in 1987 to that in 1991?
Your response must be concise. 0.9. What is the ratio of the Amount of energy used(kg of oil equivalent per capita) of Latin America(developing only) in 1987 to that in 1992?
Offer a terse response. 1.02. What is the ratio of the Amount of energy used(kg of oil equivalent per capita) in Sub-Saharan Africa (developing only) in 1987 to that in 1992?
Offer a terse response. 1.07. What is the ratio of the Amount of energy used(kg of oil equivalent per capita) of Upper middle income in 1987 to that in 1992?
Provide a succinct answer. 0.9. What is the ratio of the Amount of energy used(kg of oil equivalent per capita) of Latin America(developing only) in 1988 to that in 1989?
Your answer should be compact. 0.99. What is the ratio of the Amount of energy used(kg of oil equivalent per capita) of Sub-Saharan Africa (developing only) in 1988 to that in 1989?
Make the answer very short. 1.03. What is the ratio of the Amount of energy used(kg of oil equivalent per capita) of Upper middle income in 1988 to that in 1989?
Offer a very short reply. 0.99. What is the ratio of the Amount of energy used(kg of oil equivalent per capita) of Latin America(developing only) in 1988 to that in 1990?
Your response must be concise. 1.01. What is the ratio of the Amount of energy used(kg of oil equivalent per capita) of Sub-Saharan Africa (developing only) in 1988 to that in 1990?
Offer a terse response. 1.05. What is the ratio of the Amount of energy used(kg of oil equivalent per capita) of Upper middle income in 1988 to that in 1990?
Give a very brief answer. 0.89. What is the ratio of the Amount of energy used(kg of oil equivalent per capita) of Sub-Saharan Africa (developing only) in 1988 to that in 1991?
Offer a very short reply. 1.04. What is the ratio of the Amount of energy used(kg of oil equivalent per capita) of Upper middle income in 1988 to that in 1991?
Ensure brevity in your answer.  0.92. What is the ratio of the Amount of energy used(kg of oil equivalent per capita) in Latin America(developing only) in 1988 to that in 1992?
Offer a very short reply. 1.01. What is the ratio of the Amount of energy used(kg of oil equivalent per capita) of Sub-Saharan Africa (developing only) in 1988 to that in 1992?
Keep it short and to the point. 1.08. What is the ratio of the Amount of energy used(kg of oil equivalent per capita) of Upper middle income in 1988 to that in 1992?
Your response must be concise. 0.92. What is the ratio of the Amount of energy used(kg of oil equivalent per capita) of Latin America(developing only) in 1989 to that in 1990?
Your answer should be very brief. 1.02. What is the ratio of the Amount of energy used(kg of oil equivalent per capita) in Sub-Saharan Africa (developing only) in 1989 to that in 1990?
Your answer should be very brief. 1.02. What is the ratio of the Amount of energy used(kg of oil equivalent per capita) in Upper middle income in 1989 to that in 1990?
Your response must be concise. 0.9. What is the ratio of the Amount of energy used(kg of oil equivalent per capita) of Latin America(developing only) in 1989 to that in 1991?
Your answer should be very brief. 1.02. What is the ratio of the Amount of energy used(kg of oil equivalent per capita) of Sub-Saharan Africa (developing only) in 1989 to that in 1991?
Keep it short and to the point. 1.01. What is the ratio of the Amount of energy used(kg of oil equivalent per capita) in Upper middle income in 1989 to that in 1991?
Offer a very short reply. 0.93. What is the ratio of the Amount of energy used(kg of oil equivalent per capita) of Latin America(developing only) in 1989 to that in 1992?
Make the answer very short. 1.02. What is the ratio of the Amount of energy used(kg of oil equivalent per capita) of Sub-Saharan Africa (developing only) in 1989 to that in 1992?
Your answer should be very brief. 1.05. What is the ratio of the Amount of energy used(kg of oil equivalent per capita) of Upper middle income in 1989 to that in 1992?
Offer a very short reply. 0.93. What is the ratio of the Amount of energy used(kg of oil equivalent per capita) in Sub-Saharan Africa (developing only) in 1990 to that in 1991?
Your answer should be very brief. 0.99. What is the ratio of the Amount of energy used(kg of oil equivalent per capita) in Upper middle income in 1990 to that in 1991?
Your answer should be very brief. 1.03. What is the ratio of the Amount of energy used(kg of oil equivalent per capita) in Latin America(developing only) in 1990 to that in 1992?
Provide a succinct answer. 1.01. What is the ratio of the Amount of energy used(kg of oil equivalent per capita) in Sub-Saharan Africa (developing only) in 1990 to that in 1992?
Keep it short and to the point. 1.03. What is the ratio of the Amount of energy used(kg of oil equivalent per capita) of Upper middle income in 1990 to that in 1992?
Keep it short and to the point. 1.03. What is the ratio of the Amount of energy used(kg of oil equivalent per capita) in Latin America(developing only) in 1991 to that in 1992?
Give a very brief answer. 1.01. What is the ratio of the Amount of energy used(kg of oil equivalent per capita) in Sub-Saharan Africa (developing only) in 1991 to that in 1992?
Offer a very short reply. 1.04. What is the ratio of the Amount of energy used(kg of oil equivalent per capita) of Upper middle income in 1991 to that in 1992?
Give a very brief answer. 1. What is the difference between the highest and the second highest Amount of energy used(kg of oil equivalent per capita) in Latin America(developing only)?
Give a very brief answer. 4.38. What is the difference between the highest and the second highest Amount of energy used(kg of oil equivalent per capita) in Sub-Saharan Africa (developing only)?
Provide a succinct answer. 2.8. What is the difference between the highest and the second highest Amount of energy used(kg of oil equivalent per capita) in Upper middle income?
Keep it short and to the point. 26.25. What is the difference between the highest and the lowest Amount of energy used(kg of oil equivalent per capita) of Latin America(developing only)?
Offer a very short reply. 25.95. What is the difference between the highest and the lowest Amount of energy used(kg of oil equivalent per capita) in Sub-Saharan Africa (developing only)?
Your answer should be compact. 51.16. What is the difference between the highest and the lowest Amount of energy used(kg of oil equivalent per capita) in Upper middle income?
Your answer should be compact. 161.63. 